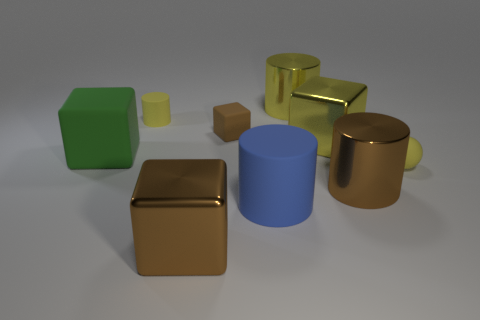How big is the brown object that is right of the blue thing?
Your response must be concise. Large. What number of big things are yellow matte balls or red metal balls?
Ensure brevity in your answer.  0. What is the color of the tiny matte thing that is the same shape as the large green matte thing?
Keep it short and to the point. Brown. Do the yellow metallic block and the blue matte cylinder have the same size?
Your answer should be very brief. Yes. What number of objects are large blue matte spheres or cubes in front of the tiny brown matte cube?
Provide a short and direct response. 3. There is a large cube that is in front of the large matte thing that is in front of the tiny yellow rubber sphere; what is its color?
Offer a terse response. Brown. Do the cylinder that is on the left side of the tiny matte block and the tiny ball have the same color?
Your answer should be very brief. Yes. What is the large block behind the green object made of?
Your answer should be compact. Metal. How big is the green cube?
Your answer should be compact. Large. Is the material of the brown object that is in front of the blue matte cylinder the same as the small brown object?
Keep it short and to the point. No. 